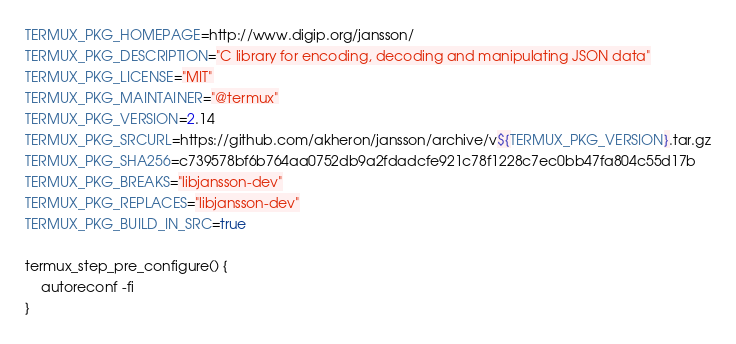Convert code to text. <code><loc_0><loc_0><loc_500><loc_500><_Bash_>TERMUX_PKG_HOMEPAGE=http://www.digip.org/jansson/
TERMUX_PKG_DESCRIPTION="C library for encoding, decoding and manipulating JSON data"
TERMUX_PKG_LICENSE="MIT"
TERMUX_PKG_MAINTAINER="@termux"
TERMUX_PKG_VERSION=2.14
TERMUX_PKG_SRCURL=https://github.com/akheron/jansson/archive/v${TERMUX_PKG_VERSION}.tar.gz
TERMUX_PKG_SHA256=c739578bf6b764aa0752db9a2fdadcfe921c78f1228c7ec0bb47fa804c55d17b
TERMUX_PKG_BREAKS="libjansson-dev"
TERMUX_PKG_REPLACES="libjansson-dev"
TERMUX_PKG_BUILD_IN_SRC=true

termux_step_pre_configure() {
	autoreconf -fi
}
</code> 